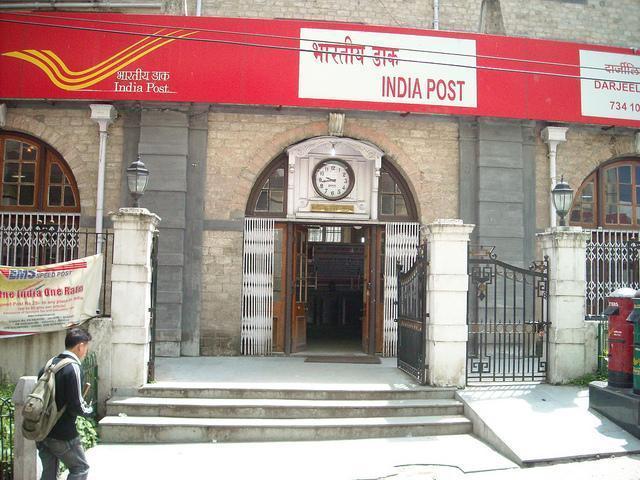How many train cars are under the poles?
Give a very brief answer. 0. 